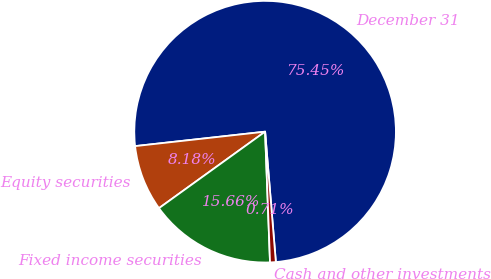<chart> <loc_0><loc_0><loc_500><loc_500><pie_chart><fcel>December 31<fcel>Equity securities<fcel>Fixed income securities<fcel>Cash and other investments<nl><fcel>75.45%<fcel>8.18%<fcel>15.66%<fcel>0.71%<nl></chart> 